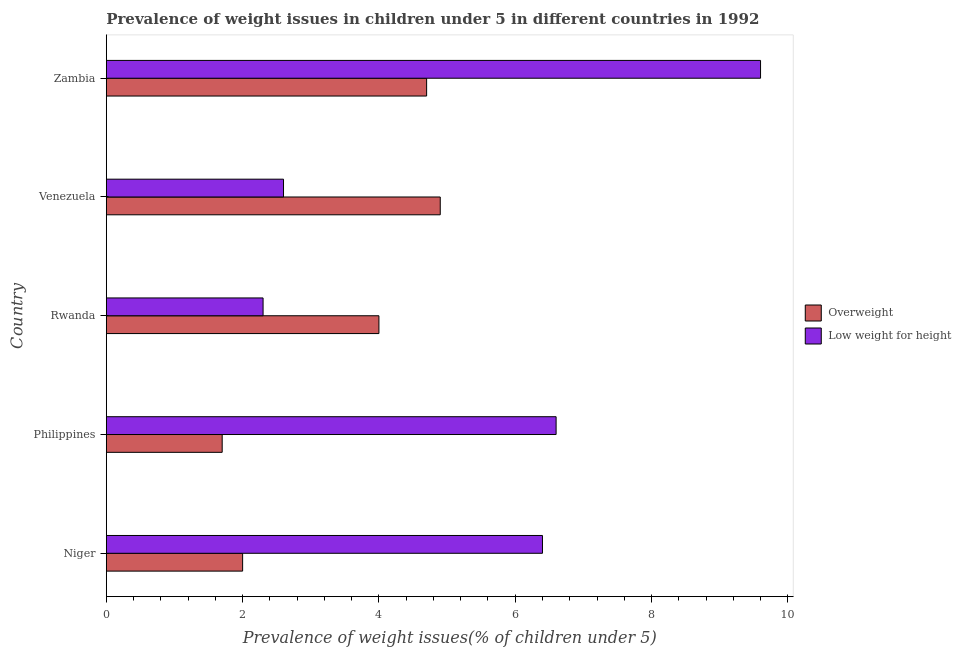How many different coloured bars are there?
Give a very brief answer. 2. How many groups of bars are there?
Ensure brevity in your answer.  5. Are the number of bars per tick equal to the number of legend labels?
Give a very brief answer. Yes. Are the number of bars on each tick of the Y-axis equal?
Your answer should be compact. Yes. How many bars are there on the 3rd tick from the top?
Your response must be concise. 2. What is the label of the 2nd group of bars from the top?
Your response must be concise. Venezuela. What is the percentage of underweight children in Zambia?
Your answer should be compact. 9.6. Across all countries, what is the maximum percentage of overweight children?
Provide a succinct answer. 4.9. Across all countries, what is the minimum percentage of overweight children?
Make the answer very short. 1.7. In which country was the percentage of overweight children maximum?
Provide a succinct answer. Venezuela. What is the total percentage of overweight children in the graph?
Your answer should be compact. 17.3. What is the difference between the percentage of underweight children in Niger and that in Rwanda?
Offer a terse response. 4.1. What is the difference between the percentage of underweight children in Philippines and the percentage of overweight children in Niger?
Your answer should be very brief. 4.6. What is the average percentage of overweight children per country?
Offer a terse response. 3.46. In how many countries, is the percentage of underweight children greater than 1.2000000000000002 %?
Make the answer very short. 5. What is the ratio of the percentage of underweight children in Rwanda to that in Venezuela?
Your response must be concise. 0.89. Is the difference between the percentage of underweight children in Rwanda and Venezuela greater than the difference between the percentage of overweight children in Rwanda and Venezuela?
Give a very brief answer. Yes. What is the difference between the highest and the second highest percentage of underweight children?
Your answer should be very brief. 3. In how many countries, is the percentage of underweight children greater than the average percentage of underweight children taken over all countries?
Your response must be concise. 3. Is the sum of the percentage of overweight children in Rwanda and Venezuela greater than the maximum percentage of underweight children across all countries?
Provide a succinct answer. No. What does the 2nd bar from the top in Venezuela represents?
Provide a succinct answer. Overweight. What does the 1st bar from the bottom in Venezuela represents?
Provide a short and direct response. Overweight. Are all the bars in the graph horizontal?
Your answer should be compact. Yes. How many countries are there in the graph?
Offer a very short reply. 5. Are the values on the major ticks of X-axis written in scientific E-notation?
Offer a terse response. No. Does the graph contain grids?
Your answer should be compact. No. How many legend labels are there?
Keep it short and to the point. 2. How are the legend labels stacked?
Offer a terse response. Vertical. What is the title of the graph?
Offer a very short reply. Prevalence of weight issues in children under 5 in different countries in 1992. Does "current US$" appear as one of the legend labels in the graph?
Give a very brief answer. No. What is the label or title of the X-axis?
Provide a short and direct response. Prevalence of weight issues(% of children under 5). What is the Prevalence of weight issues(% of children under 5) in Overweight in Niger?
Your answer should be compact. 2. What is the Prevalence of weight issues(% of children under 5) in Low weight for height in Niger?
Make the answer very short. 6.4. What is the Prevalence of weight issues(% of children under 5) in Overweight in Philippines?
Ensure brevity in your answer.  1.7. What is the Prevalence of weight issues(% of children under 5) of Low weight for height in Philippines?
Ensure brevity in your answer.  6.6. What is the Prevalence of weight issues(% of children under 5) of Overweight in Rwanda?
Offer a very short reply. 4. What is the Prevalence of weight issues(% of children under 5) in Low weight for height in Rwanda?
Your response must be concise. 2.3. What is the Prevalence of weight issues(% of children under 5) in Overweight in Venezuela?
Your response must be concise. 4.9. What is the Prevalence of weight issues(% of children under 5) of Low weight for height in Venezuela?
Offer a very short reply. 2.6. What is the Prevalence of weight issues(% of children under 5) of Overweight in Zambia?
Make the answer very short. 4.7. What is the Prevalence of weight issues(% of children under 5) of Low weight for height in Zambia?
Offer a very short reply. 9.6. Across all countries, what is the maximum Prevalence of weight issues(% of children under 5) of Overweight?
Your response must be concise. 4.9. Across all countries, what is the maximum Prevalence of weight issues(% of children under 5) in Low weight for height?
Keep it short and to the point. 9.6. Across all countries, what is the minimum Prevalence of weight issues(% of children under 5) of Overweight?
Your response must be concise. 1.7. Across all countries, what is the minimum Prevalence of weight issues(% of children under 5) in Low weight for height?
Offer a very short reply. 2.3. What is the total Prevalence of weight issues(% of children under 5) of Overweight in the graph?
Your answer should be compact. 17.3. What is the total Prevalence of weight issues(% of children under 5) in Low weight for height in the graph?
Your answer should be compact. 27.5. What is the difference between the Prevalence of weight issues(% of children under 5) in Overweight in Niger and that in Philippines?
Offer a very short reply. 0.3. What is the difference between the Prevalence of weight issues(% of children under 5) in Overweight in Niger and that in Rwanda?
Your response must be concise. -2. What is the difference between the Prevalence of weight issues(% of children under 5) in Low weight for height in Niger and that in Rwanda?
Offer a terse response. 4.1. What is the difference between the Prevalence of weight issues(% of children under 5) of Overweight in Niger and that in Venezuela?
Give a very brief answer. -2.9. What is the difference between the Prevalence of weight issues(% of children under 5) of Overweight in Niger and that in Zambia?
Your answer should be compact. -2.7. What is the difference between the Prevalence of weight issues(% of children under 5) in Overweight in Philippines and that in Rwanda?
Offer a very short reply. -2.3. What is the difference between the Prevalence of weight issues(% of children under 5) in Low weight for height in Philippines and that in Rwanda?
Provide a short and direct response. 4.3. What is the difference between the Prevalence of weight issues(% of children under 5) in Overweight in Philippines and that in Venezuela?
Offer a very short reply. -3.2. What is the difference between the Prevalence of weight issues(% of children under 5) in Low weight for height in Philippines and that in Venezuela?
Provide a succinct answer. 4. What is the difference between the Prevalence of weight issues(% of children under 5) of Low weight for height in Philippines and that in Zambia?
Offer a terse response. -3. What is the difference between the Prevalence of weight issues(% of children under 5) of Overweight in Rwanda and that in Venezuela?
Provide a short and direct response. -0.9. What is the difference between the Prevalence of weight issues(% of children under 5) in Low weight for height in Rwanda and that in Venezuela?
Your response must be concise. -0.3. What is the difference between the Prevalence of weight issues(% of children under 5) of Overweight in Rwanda and that in Zambia?
Your answer should be very brief. -0.7. What is the difference between the Prevalence of weight issues(% of children under 5) in Overweight in Niger and the Prevalence of weight issues(% of children under 5) in Low weight for height in Rwanda?
Offer a very short reply. -0.3. What is the difference between the Prevalence of weight issues(% of children under 5) of Overweight in Niger and the Prevalence of weight issues(% of children under 5) of Low weight for height in Venezuela?
Ensure brevity in your answer.  -0.6. What is the difference between the Prevalence of weight issues(% of children under 5) in Overweight in Niger and the Prevalence of weight issues(% of children under 5) in Low weight for height in Zambia?
Offer a very short reply. -7.6. What is the difference between the Prevalence of weight issues(% of children under 5) of Overweight in Philippines and the Prevalence of weight issues(% of children under 5) of Low weight for height in Rwanda?
Keep it short and to the point. -0.6. What is the difference between the Prevalence of weight issues(% of children under 5) of Overweight in Rwanda and the Prevalence of weight issues(% of children under 5) of Low weight for height in Zambia?
Provide a short and direct response. -5.6. What is the average Prevalence of weight issues(% of children under 5) of Overweight per country?
Offer a very short reply. 3.46. What is the difference between the Prevalence of weight issues(% of children under 5) in Overweight and Prevalence of weight issues(% of children under 5) in Low weight for height in Niger?
Provide a short and direct response. -4.4. What is the difference between the Prevalence of weight issues(% of children under 5) in Overweight and Prevalence of weight issues(% of children under 5) in Low weight for height in Rwanda?
Your answer should be very brief. 1.7. What is the ratio of the Prevalence of weight issues(% of children under 5) of Overweight in Niger to that in Philippines?
Your response must be concise. 1.18. What is the ratio of the Prevalence of weight issues(% of children under 5) in Low weight for height in Niger to that in Philippines?
Provide a short and direct response. 0.97. What is the ratio of the Prevalence of weight issues(% of children under 5) in Overweight in Niger to that in Rwanda?
Ensure brevity in your answer.  0.5. What is the ratio of the Prevalence of weight issues(% of children under 5) of Low weight for height in Niger to that in Rwanda?
Make the answer very short. 2.78. What is the ratio of the Prevalence of weight issues(% of children under 5) in Overweight in Niger to that in Venezuela?
Offer a terse response. 0.41. What is the ratio of the Prevalence of weight issues(% of children under 5) in Low weight for height in Niger to that in Venezuela?
Keep it short and to the point. 2.46. What is the ratio of the Prevalence of weight issues(% of children under 5) of Overweight in Niger to that in Zambia?
Give a very brief answer. 0.43. What is the ratio of the Prevalence of weight issues(% of children under 5) in Low weight for height in Niger to that in Zambia?
Your response must be concise. 0.67. What is the ratio of the Prevalence of weight issues(% of children under 5) of Overweight in Philippines to that in Rwanda?
Make the answer very short. 0.42. What is the ratio of the Prevalence of weight issues(% of children under 5) in Low weight for height in Philippines to that in Rwanda?
Make the answer very short. 2.87. What is the ratio of the Prevalence of weight issues(% of children under 5) in Overweight in Philippines to that in Venezuela?
Your answer should be compact. 0.35. What is the ratio of the Prevalence of weight issues(% of children under 5) in Low weight for height in Philippines to that in Venezuela?
Provide a succinct answer. 2.54. What is the ratio of the Prevalence of weight issues(% of children under 5) of Overweight in Philippines to that in Zambia?
Offer a terse response. 0.36. What is the ratio of the Prevalence of weight issues(% of children under 5) in Low weight for height in Philippines to that in Zambia?
Provide a succinct answer. 0.69. What is the ratio of the Prevalence of weight issues(% of children under 5) in Overweight in Rwanda to that in Venezuela?
Provide a short and direct response. 0.82. What is the ratio of the Prevalence of weight issues(% of children under 5) of Low weight for height in Rwanda to that in Venezuela?
Ensure brevity in your answer.  0.88. What is the ratio of the Prevalence of weight issues(% of children under 5) of Overweight in Rwanda to that in Zambia?
Your answer should be compact. 0.85. What is the ratio of the Prevalence of weight issues(% of children under 5) in Low weight for height in Rwanda to that in Zambia?
Offer a very short reply. 0.24. What is the ratio of the Prevalence of weight issues(% of children under 5) in Overweight in Venezuela to that in Zambia?
Offer a terse response. 1.04. What is the ratio of the Prevalence of weight issues(% of children under 5) in Low weight for height in Venezuela to that in Zambia?
Offer a very short reply. 0.27. What is the difference between the highest and the second highest Prevalence of weight issues(% of children under 5) of Low weight for height?
Your answer should be very brief. 3. What is the difference between the highest and the lowest Prevalence of weight issues(% of children under 5) of Overweight?
Your answer should be compact. 3.2. What is the difference between the highest and the lowest Prevalence of weight issues(% of children under 5) of Low weight for height?
Provide a succinct answer. 7.3. 